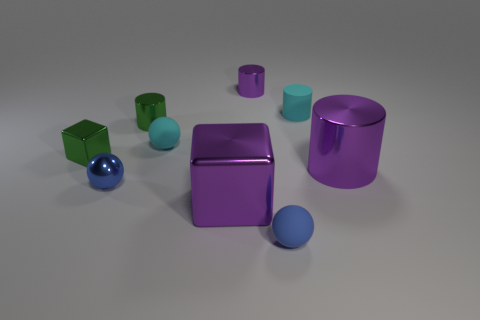Is there a large blue rubber object that has the same shape as the small blue shiny object?
Offer a terse response. No. Does the big cylinder have the same color as the shiny sphere?
Offer a terse response. No. There is a big purple object that is on the left side of the small purple thing; are there any small blue matte balls that are left of it?
Your answer should be very brief. No. How many objects are tiny green objects that are behind the tiny cyan ball or blue spheres to the left of the large purple metal cylinder?
Keep it short and to the point. 3. What number of things are yellow blocks or small cyan balls that are behind the tiny cube?
Ensure brevity in your answer.  1. There is a cyan thing that is right of the small rubber sphere that is in front of the blue object on the left side of the tiny cyan sphere; what size is it?
Ensure brevity in your answer.  Small. There is a blue object that is the same size as the metal sphere; what material is it?
Provide a succinct answer. Rubber. Are there any objects of the same size as the cyan matte sphere?
Keep it short and to the point. Yes. Do the green thing on the right side of the blue metal ball and the cyan ball have the same size?
Your answer should be compact. Yes. There is a matte thing that is both in front of the green metallic cylinder and behind the green metal cube; what is its shape?
Give a very brief answer. Sphere. 